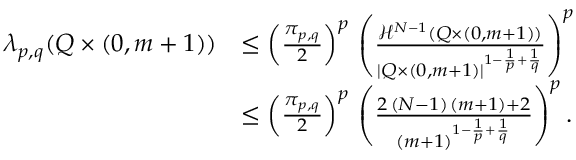<formula> <loc_0><loc_0><loc_500><loc_500>\begin{array} { r l } { \lambda _ { p , q } ( Q \times ( 0 , m + 1 ) ) } & { \leq \left ( \frac { \pi _ { p , q } } { 2 } \right ) ^ { p } \, \left ( \frac { \mathcal { H } ^ { N - 1 } ( Q \times ( 0 , m + 1 ) ) } { | Q \times ( 0 , m + 1 ) | ^ { 1 - \frac { 1 } { p } + \frac { 1 } { q } } } \right ) ^ { p } } \\ & { \leq \left ( \frac { \pi _ { p , q } } { 2 } \right ) ^ { p } \, \left ( \frac { 2 \, ( N - 1 ) \, ( m + 1 ) + 2 } { ( m + 1 ) ^ { 1 - \frac { 1 } { p } + \frac { 1 } { q } } } \right ) ^ { p } . } \end{array}</formula> 